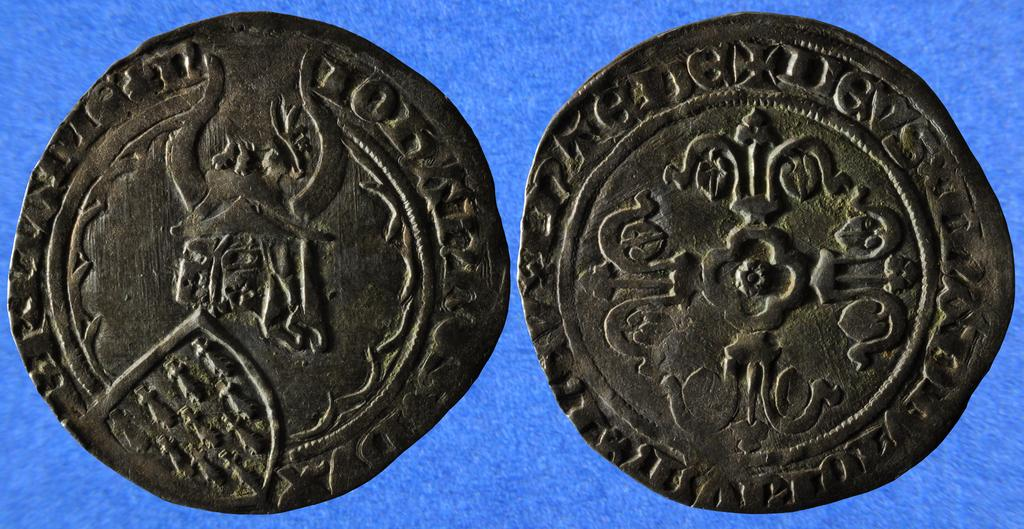What type of objects are featured in the image? There are carved coins in the image. What color is the background of the image? The background of the image is blue. How does the flame move around in the image? There is no flame present in the image; it only features carved coins and a blue background. 